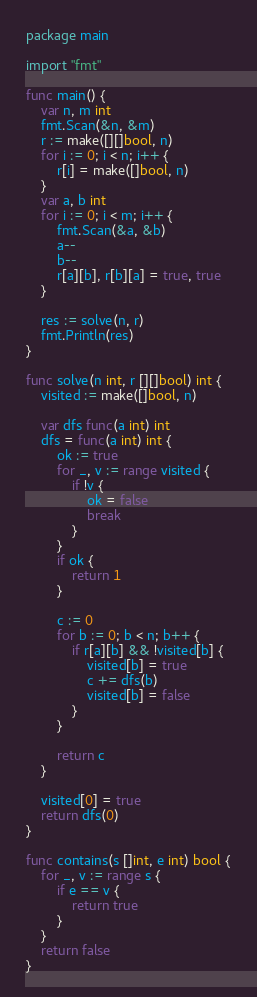Convert code to text. <code><loc_0><loc_0><loc_500><loc_500><_Go_>package main

import "fmt"

func main() {
	var n, m int
	fmt.Scan(&n, &m)
	r := make([][]bool, n)
	for i := 0; i < n; i++ {
		r[i] = make([]bool, n)
	}
	var a, b int
	for i := 0; i < m; i++ {
		fmt.Scan(&a, &b)
		a--
		b--
		r[a][b], r[b][a] = true, true
	}

	res := solve(n, r)
	fmt.Println(res)
}

func solve(n int, r [][]bool) int {
	visited := make([]bool, n)

	var dfs func(a int) int
	dfs = func(a int) int {
		ok := true
		for _, v := range visited {
			if !v {
				ok = false
				break
			}
		}
		if ok {
			return 1
		}

		c := 0
		for b := 0; b < n; b++ {
			if r[a][b] && !visited[b] {
				visited[b] = true
				c += dfs(b)
				visited[b] = false
			}
		}

		return c
	}

	visited[0] = true
	return dfs(0)
}

func contains(s []int, e int) bool {
	for _, v := range s {
		if e == v {
			return true
		}
	}
	return false
}
</code> 